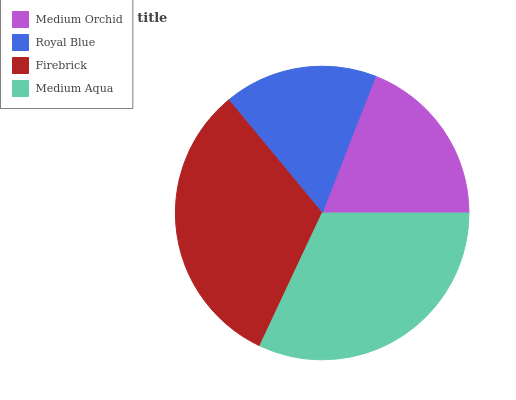Is Royal Blue the minimum?
Answer yes or no. Yes. Is Firebrick the maximum?
Answer yes or no. Yes. Is Firebrick the minimum?
Answer yes or no. No. Is Royal Blue the maximum?
Answer yes or no. No. Is Firebrick greater than Royal Blue?
Answer yes or no. Yes. Is Royal Blue less than Firebrick?
Answer yes or no. Yes. Is Royal Blue greater than Firebrick?
Answer yes or no. No. Is Firebrick less than Royal Blue?
Answer yes or no. No. Is Medium Aqua the high median?
Answer yes or no. Yes. Is Medium Orchid the low median?
Answer yes or no. Yes. Is Royal Blue the high median?
Answer yes or no. No. Is Medium Aqua the low median?
Answer yes or no. No. 